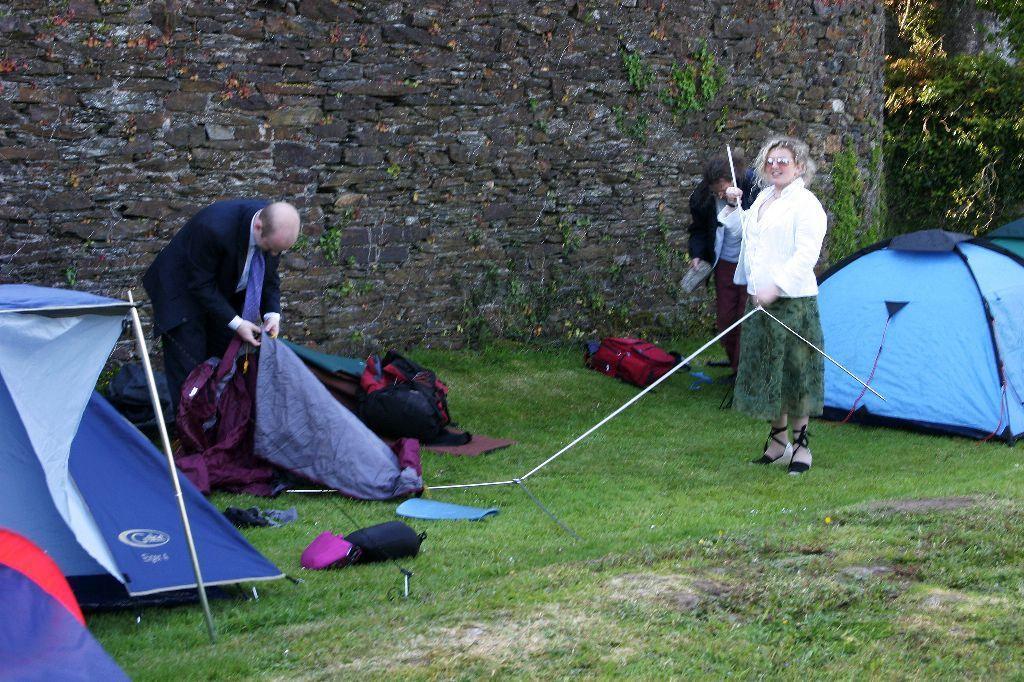Please provide a concise description of this image. This image consists of three persons. On the right, the woman is wearing a white jacket and holding a rod. On the left, the man wearing a blue suit is holding a tent. At the bottom, there is green grass on the ground. On the left and right, there are tents. In the background, there is a wall along with a tree. 